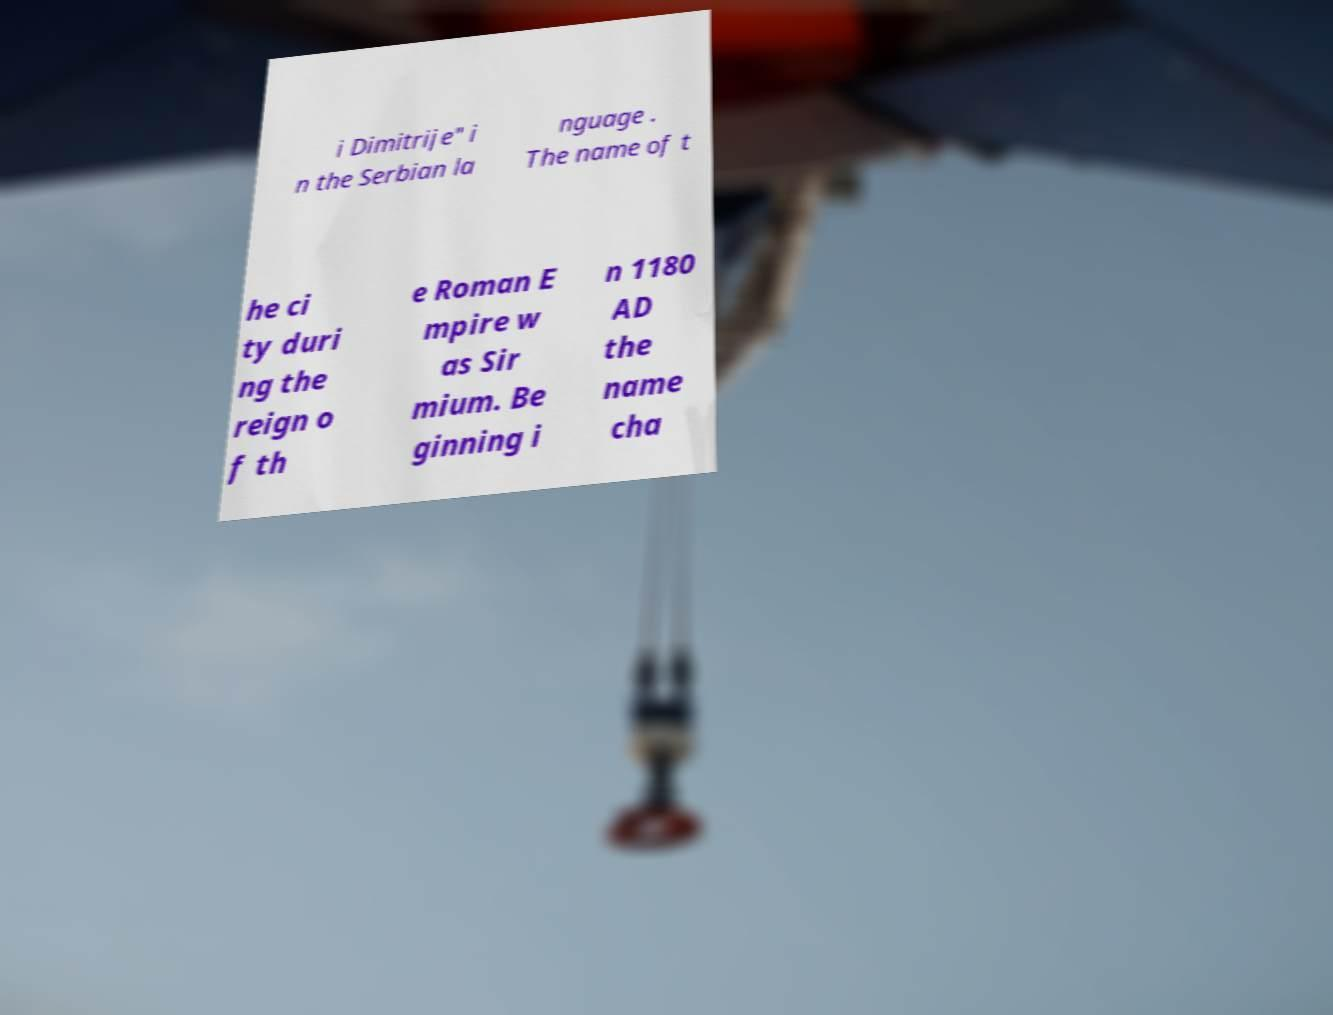Can you read and provide the text displayed in the image?This photo seems to have some interesting text. Can you extract and type it out for me? i Dimitrije" i n the Serbian la nguage . The name of t he ci ty duri ng the reign o f th e Roman E mpire w as Sir mium. Be ginning i n 1180 AD the name cha 